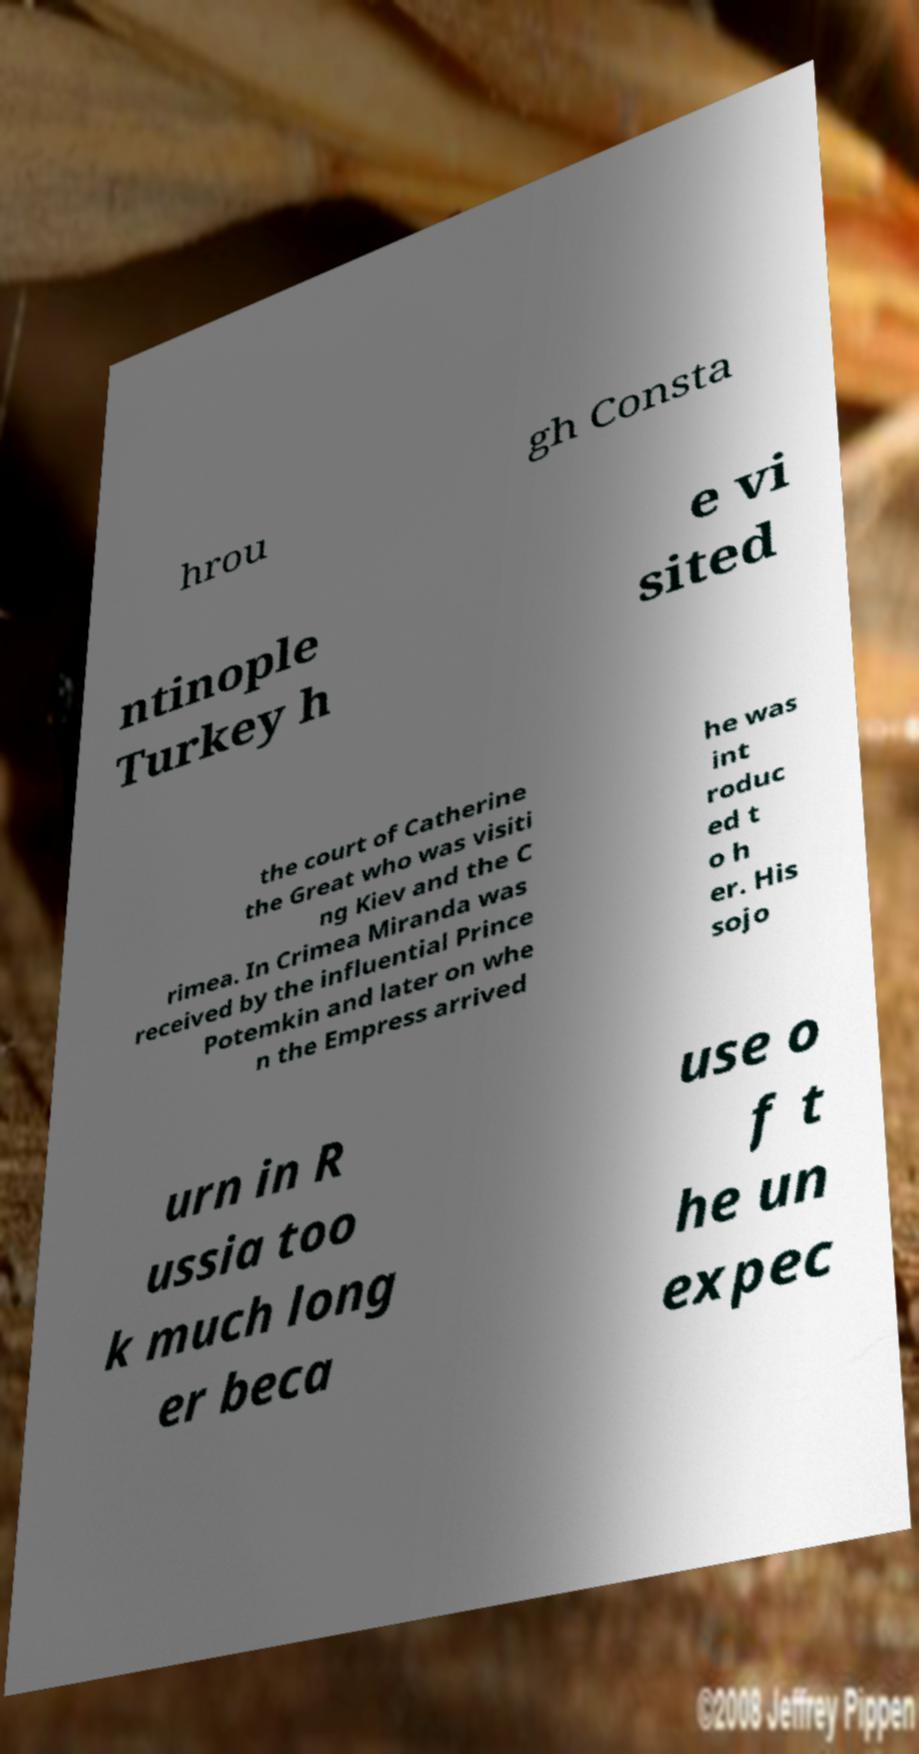Can you accurately transcribe the text from the provided image for me? hrou gh Consta ntinople Turkey h e vi sited the court of Catherine the Great who was visiti ng Kiev and the C rimea. In Crimea Miranda was received by the influential Prince Potemkin and later on whe n the Empress arrived he was int roduc ed t o h er. His sojo urn in R ussia too k much long er beca use o f t he un expec 